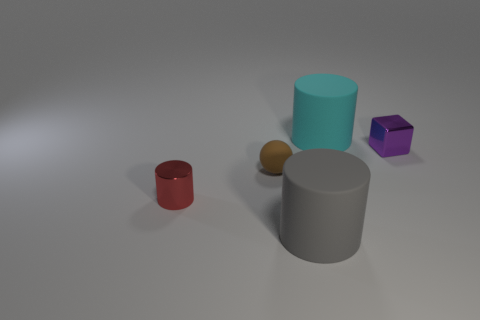How big is the rubber cylinder that is in front of the small cylinder?
Offer a very short reply. Large. How many other objects are the same shape as the big cyan object?
Your response must be concise. 2. Are there an equal number of small red cylinders to the right of the large cyan cylinder and big matte cylinders that are behind the big gray object?
Ensure brevity in your answer.  No. Does the thing in front of the tiny red object have the same material as the big cylinder that is behind the small shiny cylinder?
Your answer should be compact. Yes. What number of other things are there of the same size as the gray rubber cylinder?
Make the answer very short. 1. What number of objects are either large cyan rubber objects or large rubber cylinders that are in front of the shiny cube?
Give a very brief answer. 2. Is the number of spheres that are behind the rubber ball the same as the number of tiny purple rubber spheres?
Your answer should be very brief. Yes. The gray object that is the same material as the cyan cylinder is what shape?
Keep it short and to the point. Cylinder. What number of matte things are big gray things or tiny cyan cylinders?
Make the answer very short. 1. There is a large object behind the large gray cylinder; what number of tiny brown matte balls are right of it?
Your response must be concise. 0. 